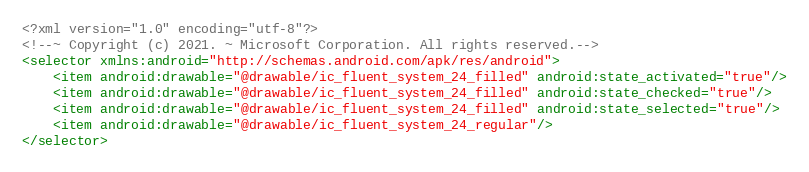<code> <loc_0><loc_0><loc_500><loc_500><_XML_><?xml version="1.0" encoding="utf-8"?>
<!--~ Copyright (c) 2021. ~ Microsoft Corporation. All rights reserved.-->
<selector xmlns:android="http://schemas.android.com/apk/res/android">
    <item android:drawable="@drawable/ic_fluent_system_24_filled" android:state_activated="true"/>
    <item android:drawable="@drawable/ic_fluent_system_24_filled" android:state_checked="true"/>
    <item android:drawable="@drawable/ic_fluent_system_24_filled" android:state_selected="true"/>
    <item android:drawable="@drawable/ic_fluent_system_24_regular"/>
</selector>
</code> 